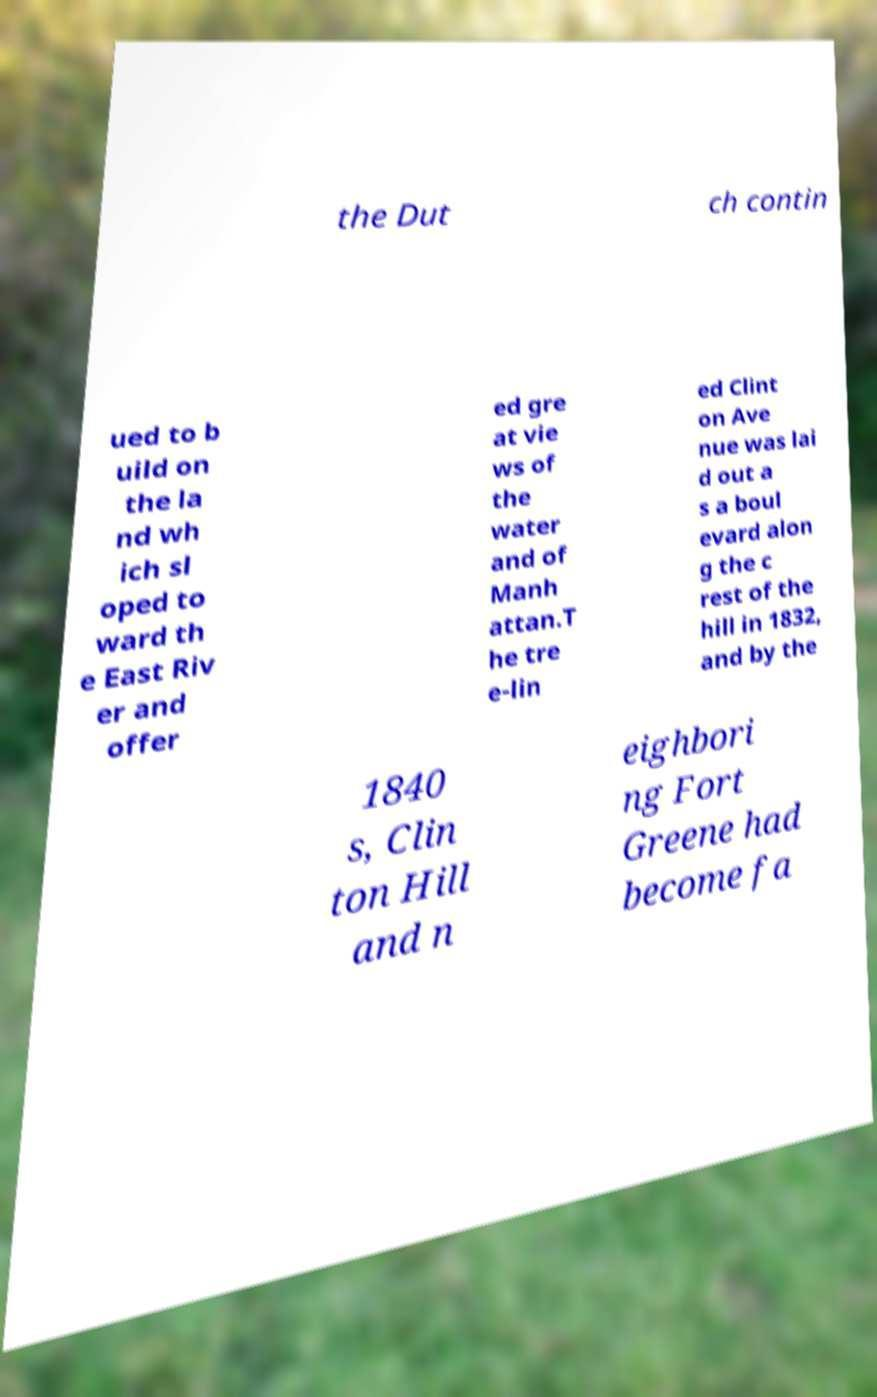Please identify and transcribe the text found in this image. the Dut ch contin ued to b uild on the la nd wh ich sl oped to ward th e East Riv er and offer ed gre at vie ws of the water and of Manh attan.T he tre e-lin ed Clint on Ave nue was lai d out a s a boul evard alon g the c rest of the hill in 1832, and by the 1840 s, Clin ton Hill and n eighbori ng Fort Greene had become fa 